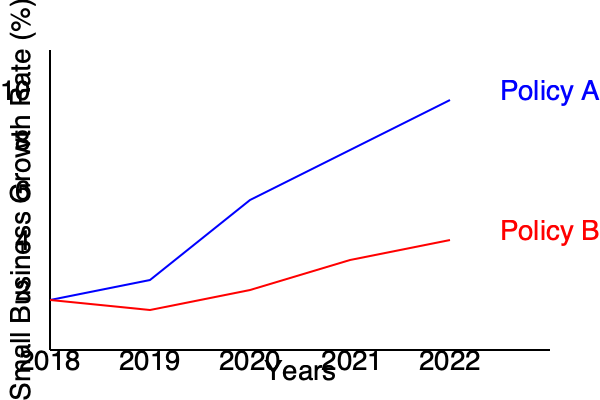As a business leader advocating for economic policies, analyze the impact of two different tax policies (A and B) on small business growth rates from 2018 to 2022. Calculate the difference in cumulative growth rates between Policy A and Policy B over the 5-year period, and determine which policy would be more beneficial for small businesses. Express your answer as a percentage difference. To analyze the impact and calculate the difference in cumulative growth rates:

1. Calculate cumulative growth rate for Policy A:
   2018: 2%
   2019: 2% + 3% = 5%
   2020: 5% + 5% = 10%
   2021: 10% + 3% = 13%
   2022: 13% + 3% = 16%
   Cumulative growth rate A = 16%

2. Calculate cumulative growth rate for Policy B:
   2018: 2%
   2019: 2% + 1% = 3%
   2020: 3% + 2% = 5%
   2021: 5% + 2% = 7%
   2022: 7% + 1% = 8%
   Cumulative growth rate B = 8%

3. Calculate the difference:
   Difference = Cumulative growth rate A - Cumulative growth rate B
   Difference = 16% - 8% = 8%

Policy A results in a higher cumulative growth rate, making it more beneficial for small businesses.
Answer: 8% higher growth rate with Policy A 